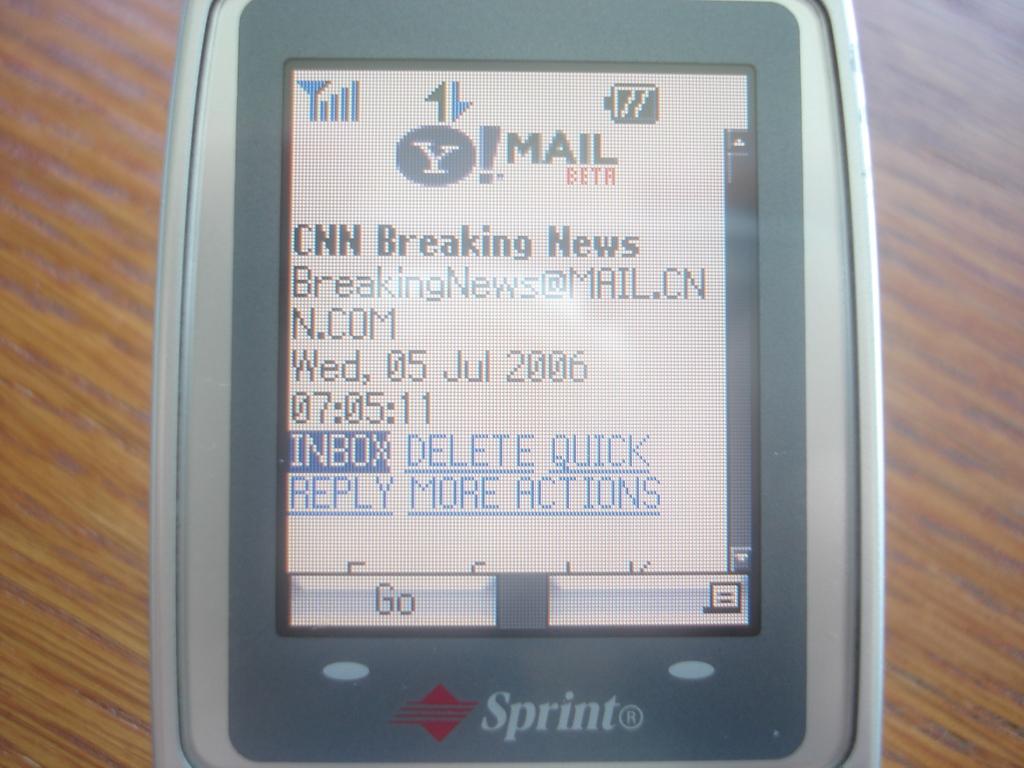What brand is this phone?
Offer a very short reply. Sprint. 